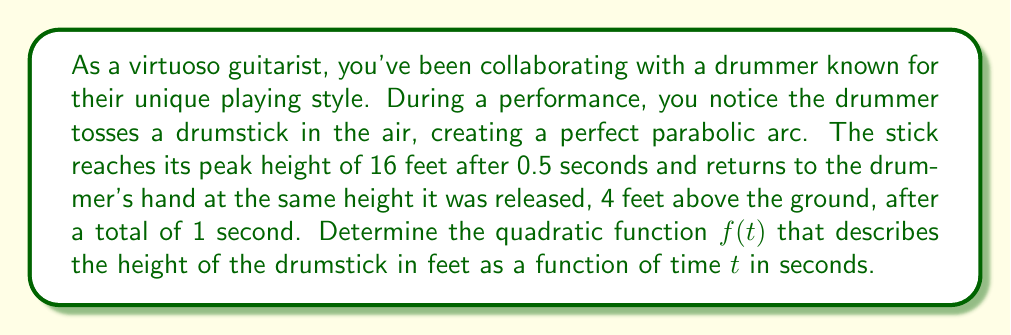Can you solve this math problem? Let's approach this step-by-step:

1) The general form of a quadratic function is $f(t) = a(t-h)^2 + k$, where $(h,k)$ is the vertex of the parabola.

2) We know the vertex occurs at $t = 0.5$ seconds and a height of 16 feet. So, $h = 0.5$ and $k = 16$.

3) We can now write our function as $f(t) = a(t-0.5)^2 + 16$

4) To find $a$, we can use the information that the stick returns to 4 feet after 1 second:

   $4 = a(1-0.5)^2 + 16$
   $4 = a(0.5)^2 + 16$
   $4 = 0.25a + 16$
   $-12 = 0.25a$
   $a = -48$

5) Therefore, our quadratic function is:

   $f(t) = -48(t-0.5)^2 + 16$

6) We can expand this to standard form $at^2 + bt + c$:

   $f(t) = -48(t^2 - t + 0.25) + 16$
   $f(t) = -48t^2 + 48t - 12 + 16$
   $f(t) = -48t^2 + 48t + 4$

This function describes the height of the drumstick at any given time $t$ during its 1-second flight.
Answer: $f(t) = -48t^2 + 48t + 4$ 